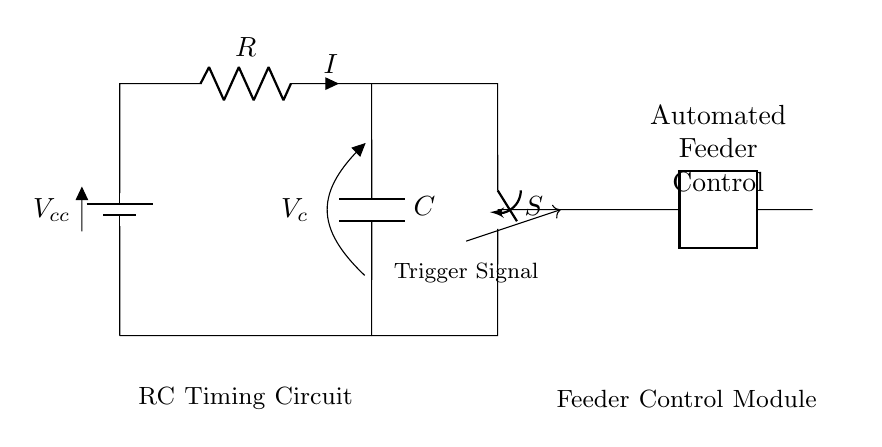What is the type of components used in this circuit? The circuit consists of a resistor, capacitor, a battery, a switch, and a control module which implies it is an RC circuit.
Answer: RC circuit What is the role of the switch in this circuit? The switch controls the connection between the power supply and the RC timing circuit. When closed, it allows current to flow, affecting the timing and control functionality.
Answer: Control connection What is the voltage source in this circuit? The voltage source is labeled as Vcc, which suggests it is providing the supply voltage for the circuit operation.
Answer: Vcc How does the trigger signal interact with the circuit? The trigger signal from the RC timer module is sent to the feeder control module to indicate when to activate the automated feeder, signifying the completion of the timing cycle.
Answer: Activates feeder What is the function of the capacitor in this circuit? The capacitor stores and releases electrical energy, determining the timing of the circuit by charging and discharging, which affects the operation of the automated feeder.
Answer: Timing function What is the role of the resistor in the timing behavior? The resistor controls the rate at which the capacitor charges and discharges, influencing the timing interval before the feeder is activated or deactivated.
Answer: Rate control What happens when the switch is closed? When the switch is closed, the circuit is completed, allowing current to flow through the resistor and capacitor, which initiates the timing process for activating the automated feeder.
Answer: Circuit activates 